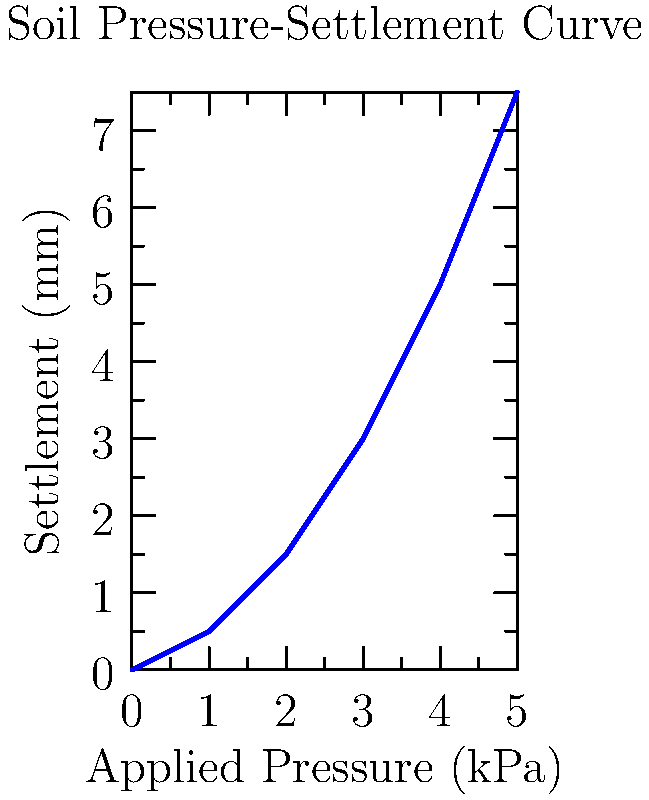As a trauma therapist, you're working with a client who's experiencing anxiety about the structural integrity of their new home. To help them understand and process their concerns, you decide to explain the concept of foundation settlement. Using the soil pressure-settlement curve provided, calculate the expected settlement (in mm) when the applied pressure is 3.5 kPa. How might you use this information to help your client process their anxiety? Let's approach this step-by-step:

1) First, we need to understand what the graph represents. The x-axis shows the applied pressure in kPa, and the y-axis shows the settlement in mm.

2) We're asked to find the settlement when the applied pressure is 3.5 kPa.

3) Looking at the graph, we can see that 3.5 kPa falls between 3 kPa and 4 kPa on the x-axis.

4) At 3 kPa, the settlement is 3 mm.
   At 4 kPa, the settlement is 5 mm.

5) We can use linear interpolation to estimate the settlement at 3.5 kPa:

   $$\text{Settlement} = 3 + \frac{3.5 - 3}{4 - 3} \times (5 - 3) = 3 + 0.5 \times 2 = 4 \text{ mm}$$

6) Therefore, the expected settlement when the applied pressure is 3.5 kPa is 4 mm.

As a trauma therapist, you can use this information to help your client process their anxiety by:

a) Explaining that some settlement is normal and expected in all buildings.
b) Highlighting that the settlement is very small (only 4 mm) for a significant pressure.
c) Discussing how engineers use this type of data to design safe foundations.
d) Encouraging the client to focus on the facts and data rather than their fears.
e) Using this as an opportunity to practice grounding techniques, relating the solid foundation to their own emotional stability.
Answer: 4 mm 